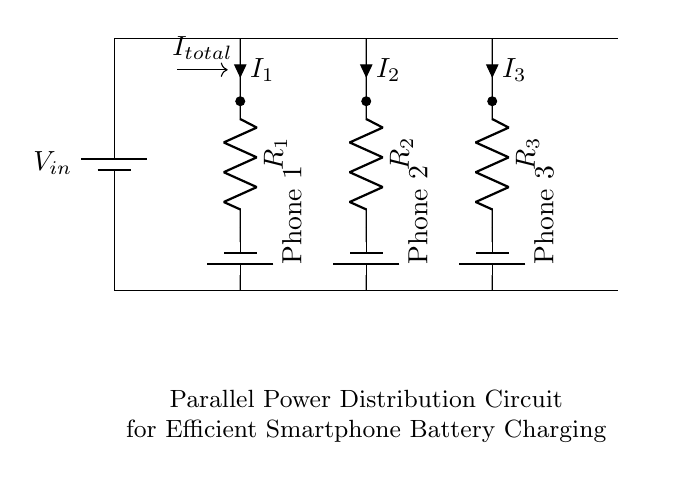What is the type of circuit shown? The circuit is a parallel circuit, evident from the multiple branches connecting to the same power source while maintaining separate paths for current flow.
Answer: parallel How many phones are connected to the circuit? There are three phones connected, as indicated by the three distinct branches leading to three separate batteries labeled "Phone 1," "Phone 2," and "Phone 3."
Answer: three What does "I total" represent in the circuit? "I total" represents the total current flowing out of the power source, which is divided among the three branches connected to the phones. This is characteristic of parallel circuits where total current equals the sum of the currents in each branch.
Answer: total current What does "R" stand for in the circuit? "R" stands for resistance in ohms, which is shown by the three resistors labeled R1, R2, and R3 positioned in series between the distribution line and each phone to control the current flow.
Answer: resistance What will happen if one phone is disconnected? If one phone is disconnected, the other phones will continue to charge because the circuit is designed in parallel, allowing current to flow through unaffected branches.
Answer: unaffected charging What is the direction of current flow in this circuit? The direction of current flow is from the power source (battery) toward each phone, as indicated by the conventional current arrows pointing from positive to negative.
Answer: toward the phones 